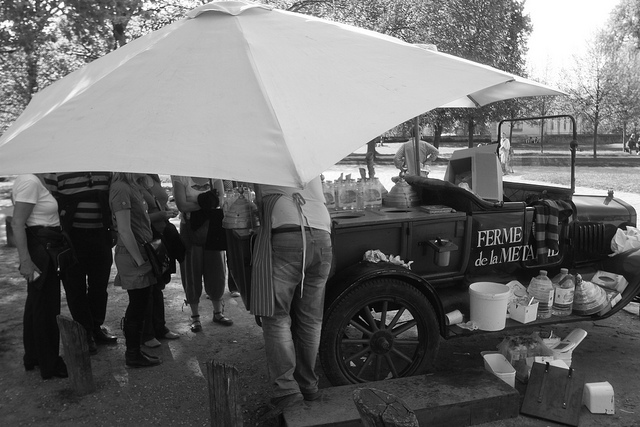Please identify all text content in this image. FERME RME la de 